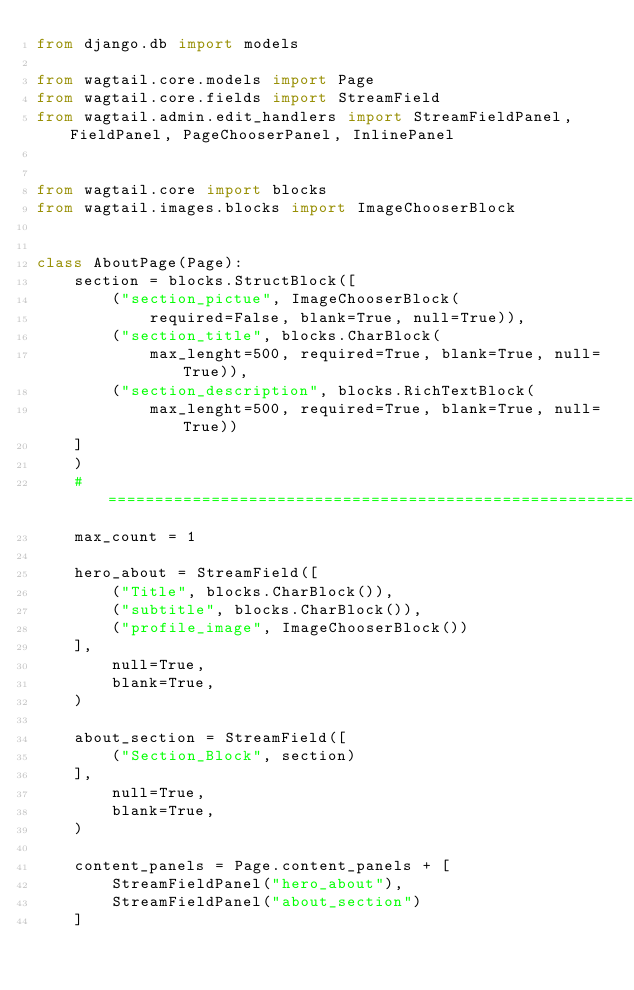<code> <loc_0><loc_0><loc_500><loc_500><_Python_>from django.db import models

from wagtail.core.models import Page
from wagtail.core.fields import StreamField
from wagtail.admin.edit_handlers import StreamFieldPanel, FieldPanel, PageChooserPanel, InlinePanel


from wagtail.core import blocks
from wagtail.images.blocks import ImageChooserBlock


class AboutPage(Page):
    section = blocks.StructBlock([
        ("section_pictue", ImageChooserBlock(
            required=False, blank=True, null=True)),
        ("section_title", blocks.CharBlock(
            max_lenght=500, required=True, blank=True, null=True)),
        ("section_description", blocks.RichTextBlock(
            max_lenght=500, required=True, blank=True, null=True))
    ]
    )
    # ===========================================================================
    max_count = 1

    hero_about = StreamField([
        ("Title", blocks.CharBlock()),
        ("subtitle", blocks.CharBlock()),
        ("profile_image", ImageChooserBlock())
    ],
        null=True,
        blank=True,
    )

    about_section = StreamField([
        ("Section_Block", section)
    ],
        null=True,
        blank=True,
    )

    content_panels = Page.content_panels + [
        StreamFieldPanel("hero_about"),
        StreamFieldPanel("about_section")
    ]
</code> 